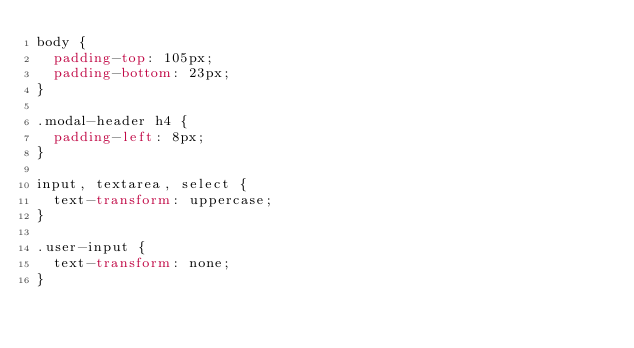Convert code to text. <code><loc_0><loc_0><loc_500><loc_500><_CSS_>body {
  padding-top: 105px;
  padding-bottom: 23px;
}

.modal-header h4 {
  padding-left: 8px;
}

input, textarea, select {
  text-transform: uppercase;
}

.user-input {
  text-transform: none;
}
</code> 